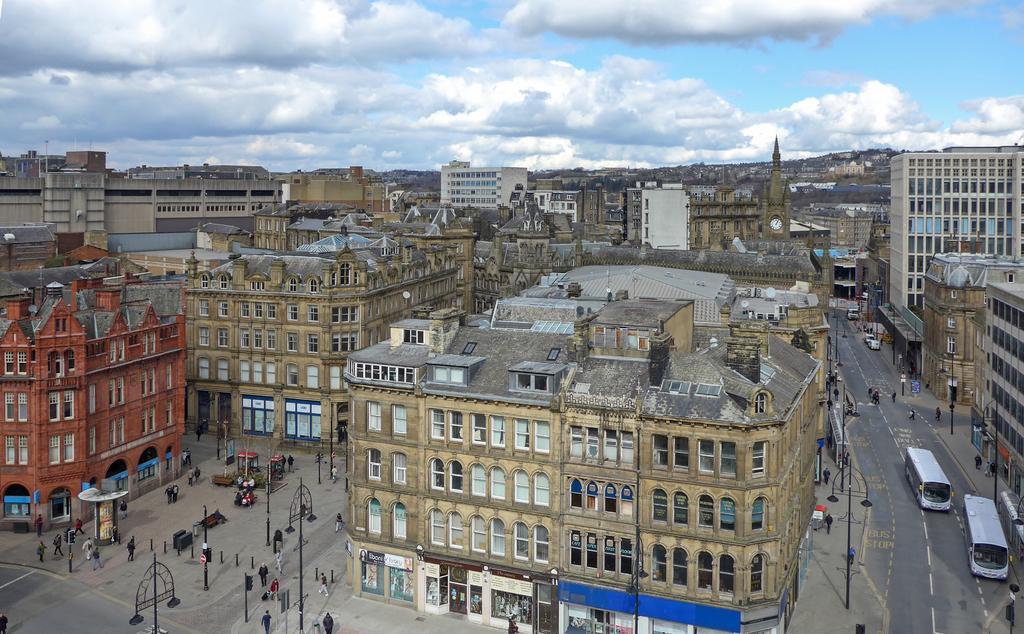In one or two sentences, can you explain what this image depicts? In this image I can see the ground, few persons on the ground, few poles, the road, few vehicles on the road and few buildings. In the background I can see the sky. 